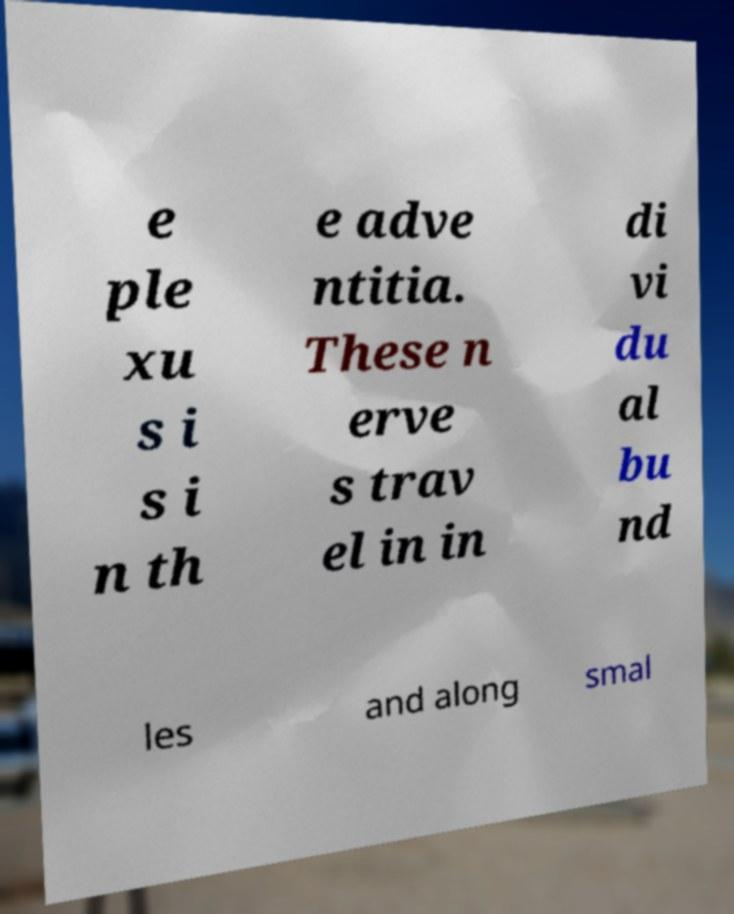Please identify and transcribe the text found in this image. e ple xu s i s i n th e adve ntitia. These n erve s trav el in in di vi du al bu nd les and along smal 